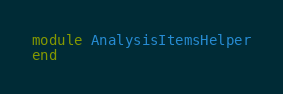Convert code to text. <code><loc_0><loc_0><loc_500><loc_500><_Ruby_>module AnalysisItemsHelper
end
</code> 